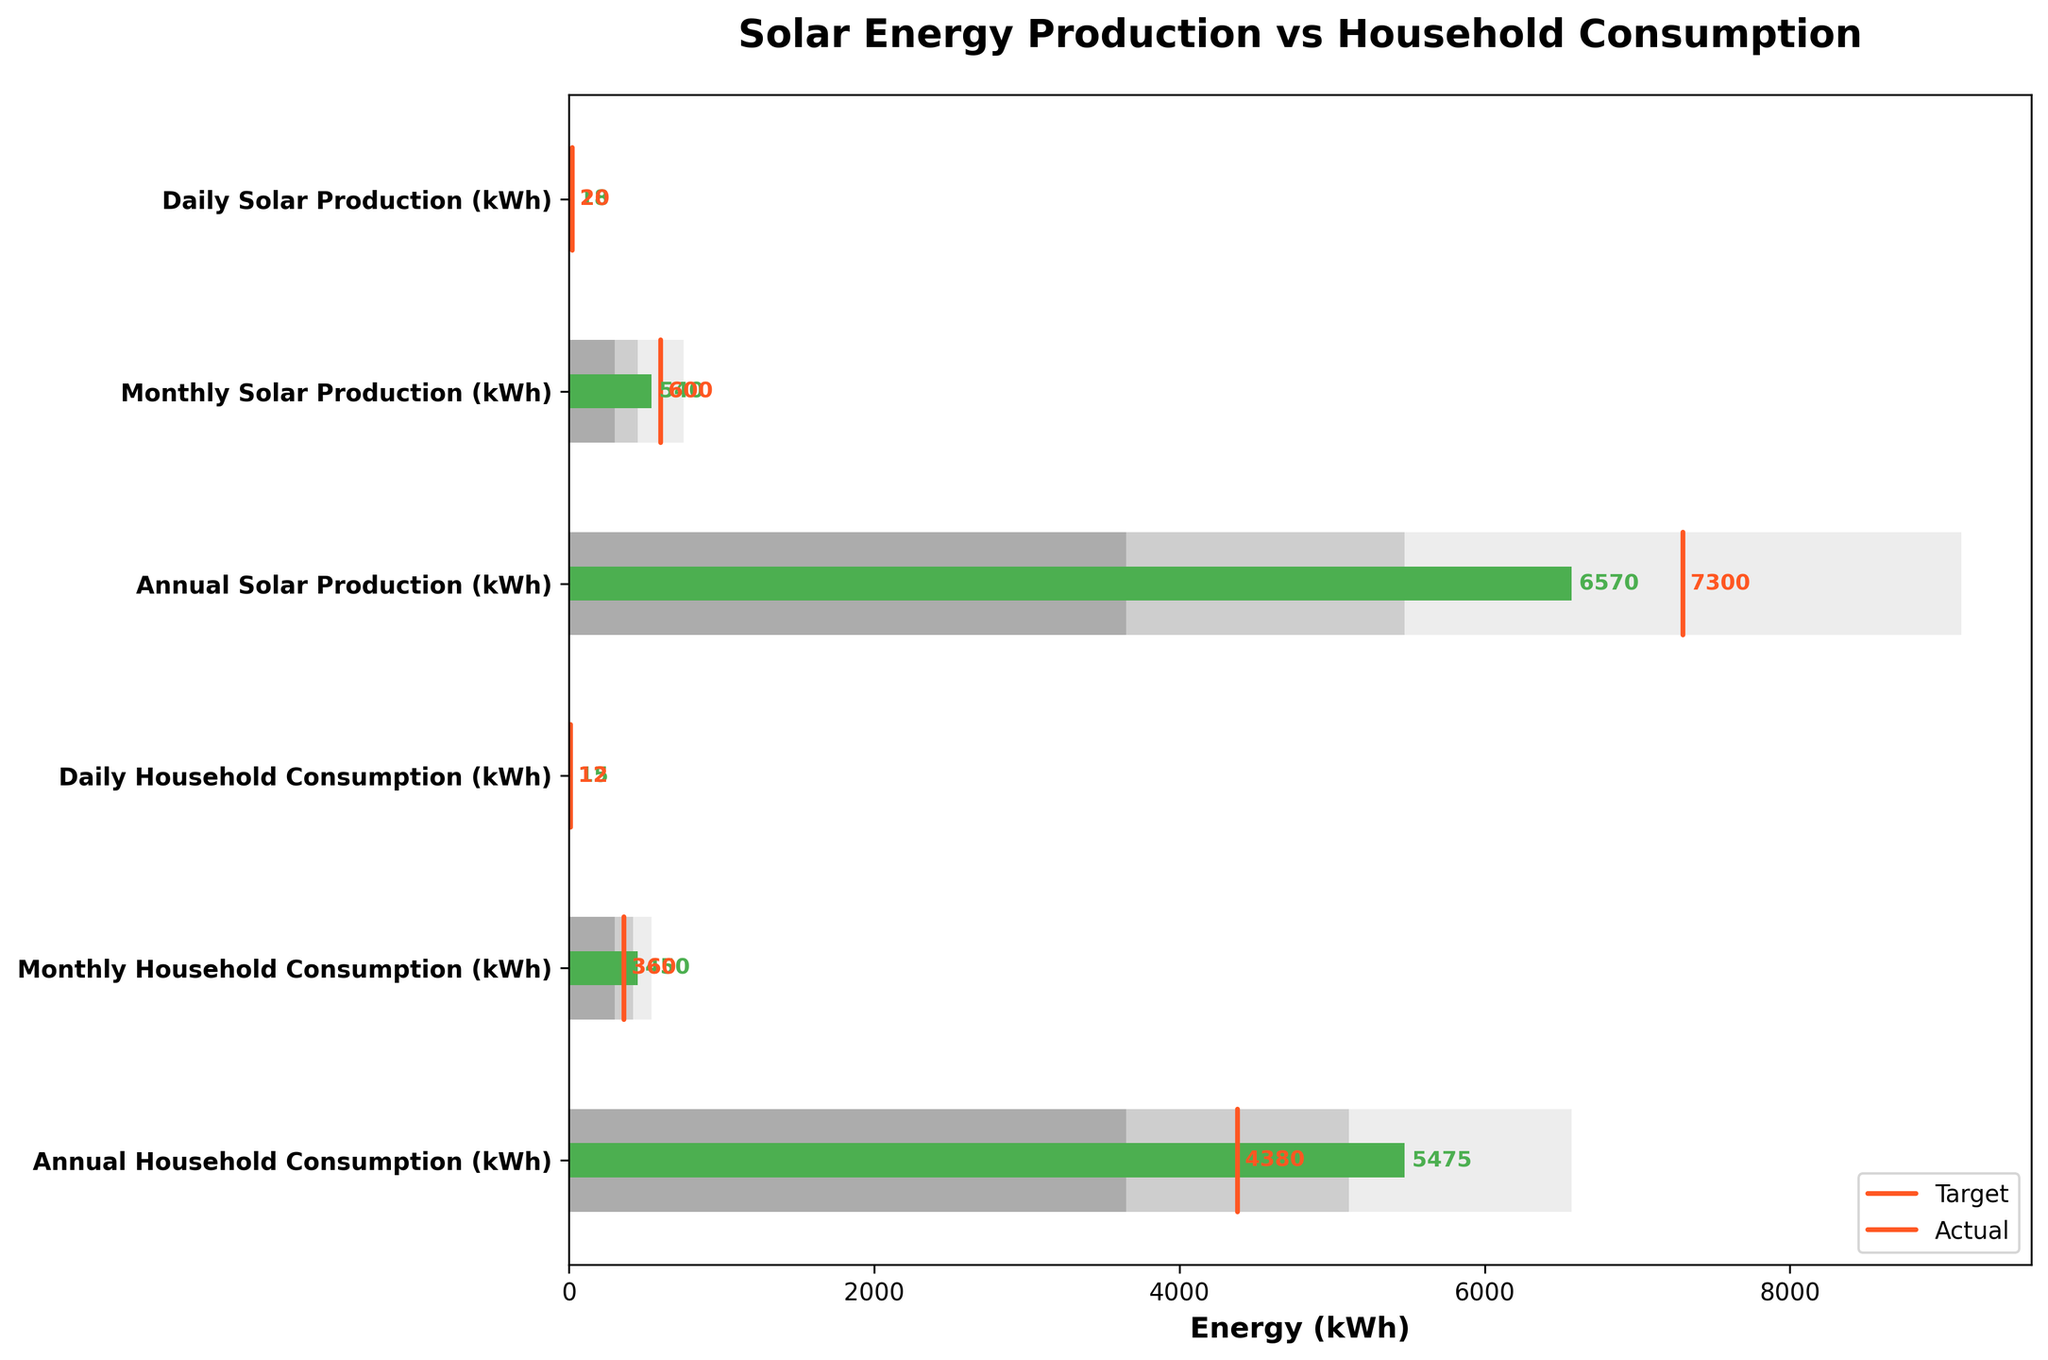what is the title of the chart? The title of the chart is shown at the top of the figure.
Answer: Solar Energy Production vs Household Consumption What is the target value for daily solar production? The target value for daily solar production is indicated by the orange vertical line in the corresponding section of the chart.
Answer: 20 kWh Which has a higher actual daily value, solar production or household consumption? By comparing the green bars for daily values, the actual value of daily solar production (18 kWh) is higher than that of daily household consumption (15 kWh).
Answer: Solar production How much is the difference between annual solar production and annual household consumption? The difference is found by subtracting the annual household consumption (5475 kWh) from the annual solar production (6570 kWh). 6570 - 5475 = 1095 kWh.
Answer: 1095 kWh Is monthly household consumption within the optimal range specified in the figure? The optimal range for monthly household consumption is 300 to 420 kWh. Checking the actual value of 450 kWh, we see it is outside the optimal range.
Answer: No What are the actual and target values for monthly solar production? The actual value for monthly solar production is represented by the green bar and the target value by the orange line.
Answer: Actual: 540 kWh, Target: 600 kWh Which data point is closest to its target value? Comparing the difference between the actual and target values for all points, the closest is 15 - 12 = 3 kWh for daily household consumption.
Answer: Daily household consumption How many data points fall within the determined ranges? To answer, we check if the actual values fall within the Range1, Range2, or Range3 for each data point.
Answer: 4 (Daily Solar Production, Daily Household Consumption, Monthly Solar Production, Monthly Household Production) In what ways does the chart show that monthly solar production is exceeding some range values? Monthly solar production's actual value of 540 kWh falls into the higher end of its Range3, indicating it exceeds the lower and middle range values.
Answer: Range2 and Range1 What is the color used to represent the actual values in the chart? The actual values are shown as green bars on the chart.
Answer: Green 